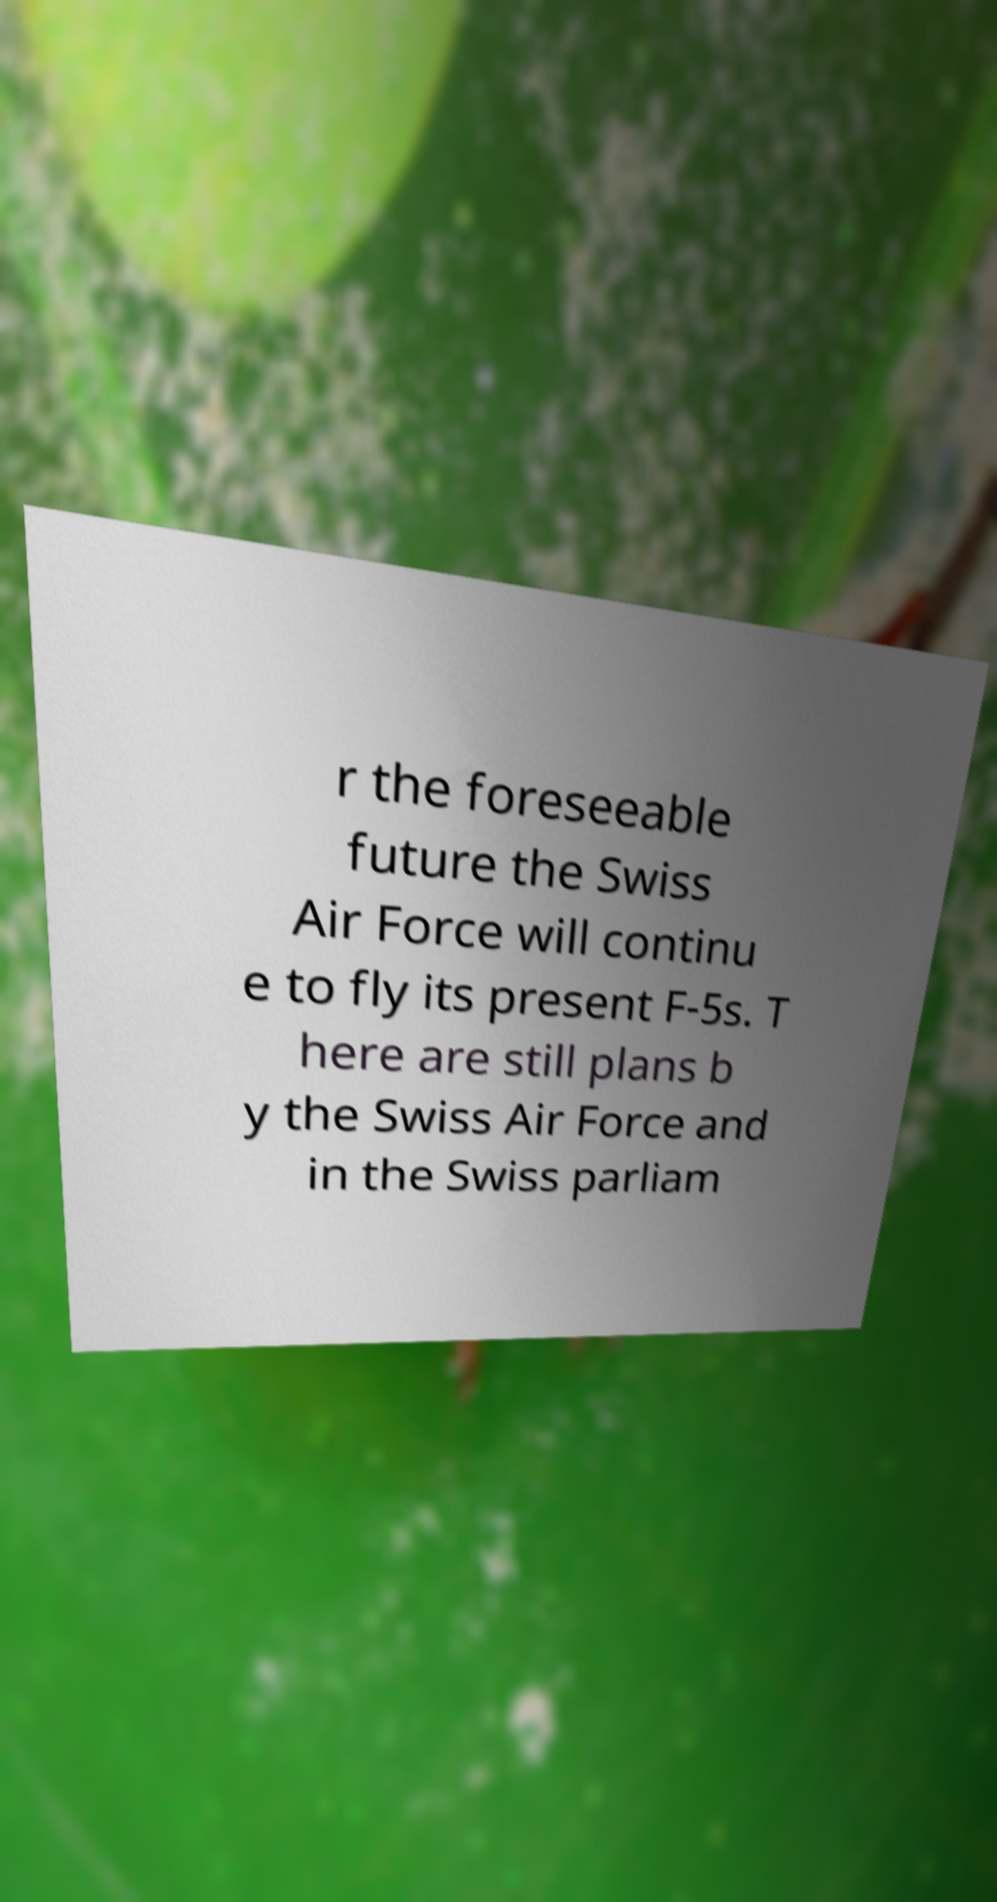Could you assist in decoding the text presented in this image and type it out clearly? r the foreseeable future the Swiss Air Force will continu e to fly its present F-5s. T here are still plans b y the Swiss Air Force and in the Swiss parliam 